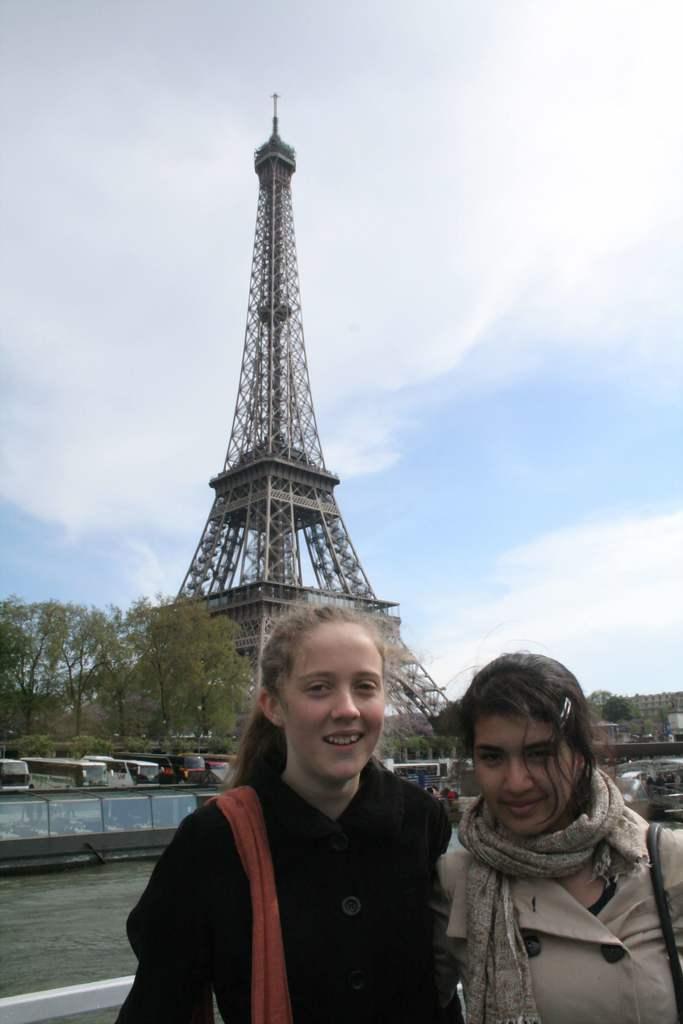In one or two sentences, can you explain what this image depicts? There are two women standing and carrying bags on their shoulder. In the background there are vehicles,trees,buildings,clouds in the sky and Eiffel tower. 